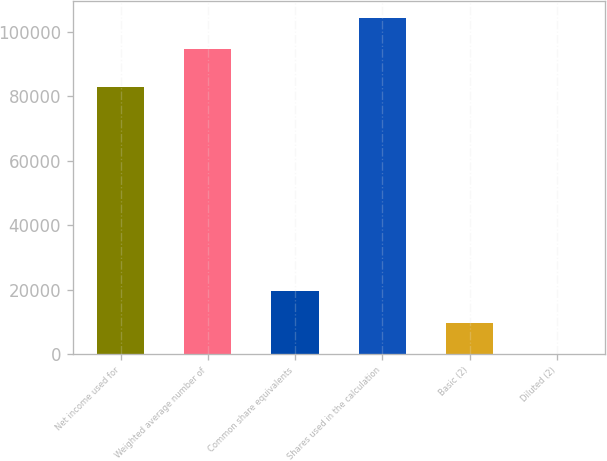Convert chart. <chart><loc_0><loc_0><loc_500><loc_500><bar_chart><fcel>Net income used for<fcel>Weighted average number of<fcel>Common share equivalents<fcel>Shares used in the calculation<fcel>Basic (2)<fcel>Diluted (2)<nl><fcel>82964<fcel>94658<fcel>19510.5<fcel>104413<fcel>9755.67<fcel>0.85<nl></chart> 